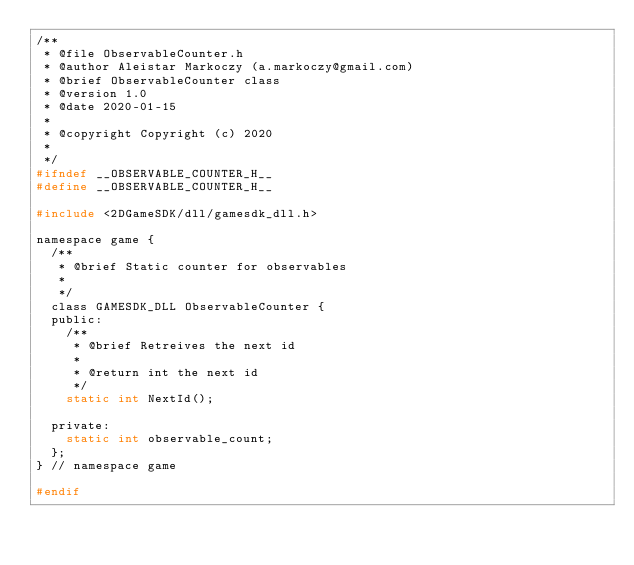Convert code to text. <code><loc_0><loc_0><loc_500><loc_500><_C_>/**
 * @file ObservableCounter.h
 * @author Aleistar Markoczy (a.markoczy@gmail.com)
 * @brief ObservableCounter class
 * @version 1.0
 * @date 2020-01-15
 * 
 * @copyright Copyright (c) 2020
 * 
 */
#ifndef __OBSERVABLE_COUNTER_H__
#define __OBSERVABLE_COUNTER_H__

#include <2DGameSDK/dll/gamesdk_dll.h>

namespace game {
  /**
   * @brief Static counter for observables
   * 
   */
  class GAMESDK_DLL ObservableCounter {
  public:
    /**
     * @brief Retreives the next id
     * 
     * @return int the next id
     */
    static int NextId();

  private:
    static int observable_count;
  };
} // namespace game

#endif</code> 